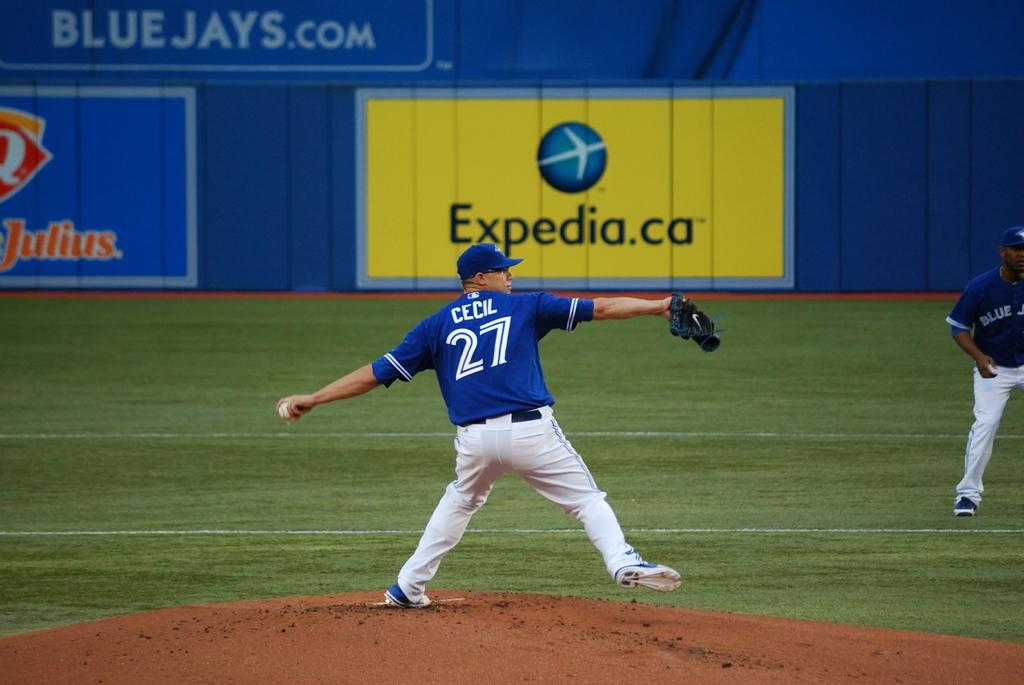What number jersey does the player throwing the ball wear?
Ensure brevity in your answer.  27. 